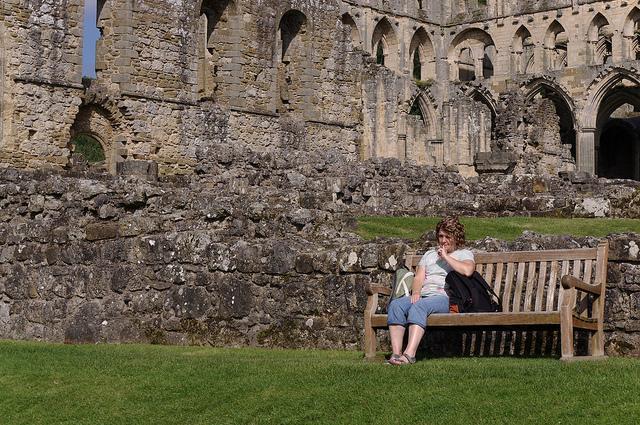What activity happens near and in this structure?
Select the accurate response from the four choices given to answer the question.
Options: Baseball, tourism, office work, banking. Tourism. 